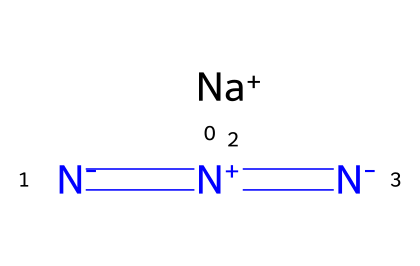What is the total number of atoms in sodium azide? The SMILES representation shows one sodium (Na) atom and three nitrogen (N) atoms. Adding these together, there are a total of four atoms.
Answer: four How many nitrogen atoms are present in sodium azide? By examining the SMILES, we see there are three nitrogen atoms represented by [N-]=[N+]=[N-].
Answer: three What type of bonding is predominantly seen in sodium azide? The chemical structure contains multiple double bonds between the nitrogen atoms, indicating that there are resonance structures involving double bonds in azides. Specifically, the [N-]=[N+]=[N-] shows that these nitrogen atoms are interconnected through double bonds.
Answer: double bonds What charge does sodium have in this compound? In the given SMILES representation, sodium is denoted as [Na+], indicating a positive charge on the sodium atom.
Answer: positive How is sodium azide classified in terms of its functional group? Sodium azide contains the azide group represented by the [N-]=[N+]=[N-] structure, which is characteristic of azides. Therefore, it is classified as an azide compound.
Answer: azide What does the presence of three nitrogen atoms suggest about the chemical behavior of sodium azide? The three nitrogen atoms allow for the potential for energy release through decomposition, as azides are known to be explosive and unstable under certain conditions. Their structure suggests high reactivity, especially upon thermal or shock initiation.
Answer: explosive 